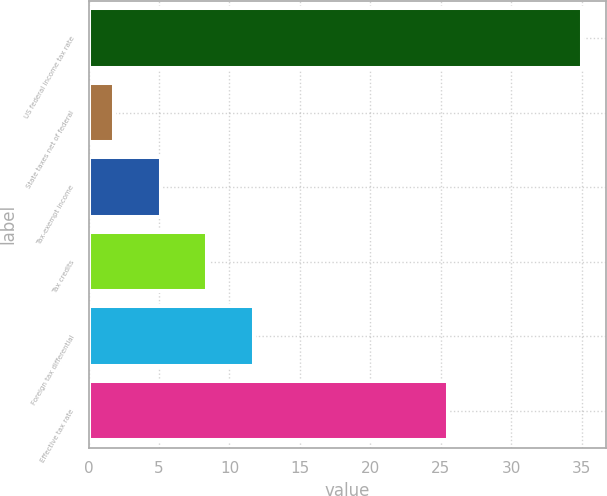Convert chart. <chart><loc_0><loc_0><loc_500><loc_500><bar_chart><fcel>US federal income tax rate<fcel>State taxes net of federal<fcel>Tax-exempt income<fcel>Tax credits<fcel>Foreign tax differential<fcel>Effective tax rate<nl><fcel>35<fcel>1.8<fcel>5.12<fcel>8.44<fcel>11.76<fcel>25.5<nl></chart> 